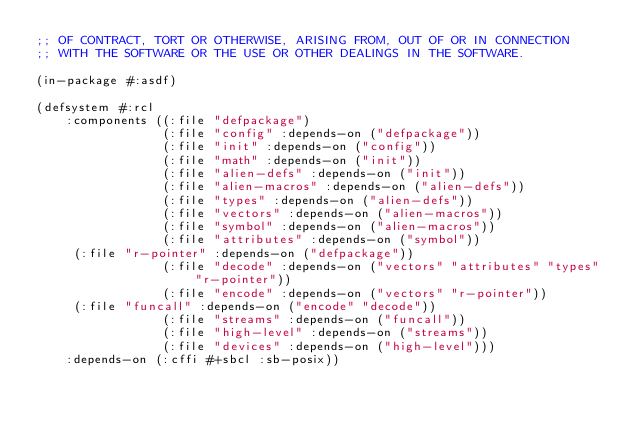<code> <loc_0><loc_0><loc_500><loc_500><_Lisp_>;; OF CONTRACT, TORT OR OTHERWISE, ARISING FROM, OUT OF OR IN CONNECTION
;; WITH THE SOFTWARE OR THE USE OR OTHER DEALINGS IN THE SOFTWARE.

(in-package #:asdf)

(defsystem #:rcl
    :components ((:file "defpackage")
                 (:file "config" :depends-on ("defpackage"))
                 (:file "init" :depends-on ("config"))
                 (:file "math" :depends-on ("init"))
                 (:file "alien-defs" :depends-on ("init"))	
                 (:file "alien-macros" :depends-on ("alien-defs"))	
                 (:file "types" :depends-on ("alien-defs"))	
                 (:file "vectors" :depends-on ("alien-macros"))
                 (:file "symbol" :depends-on ("alien-macros"))
                 (:file "attributes" :depends-on ("symbol"))
		 (:file "r-pointer" :depends-on ("defpackage"))
                 (:file "decode" :depends-on ("vectors" "attributes" "types" "r-pointer"))
                 (:file "encode" :depends-on ("vectors" "r-pointer"))
		 (:file "funcall" :depends-on ("encode" "decode"))
                 (:file "streams" :depends-on ("funcall"))	
                 (:file "high-level" :depends-on ("streams"))
                 (:file "devices" :depends-on ("high-level")))
    :depends-on (:cffi #+sbcl :sb-posix))
</code> 